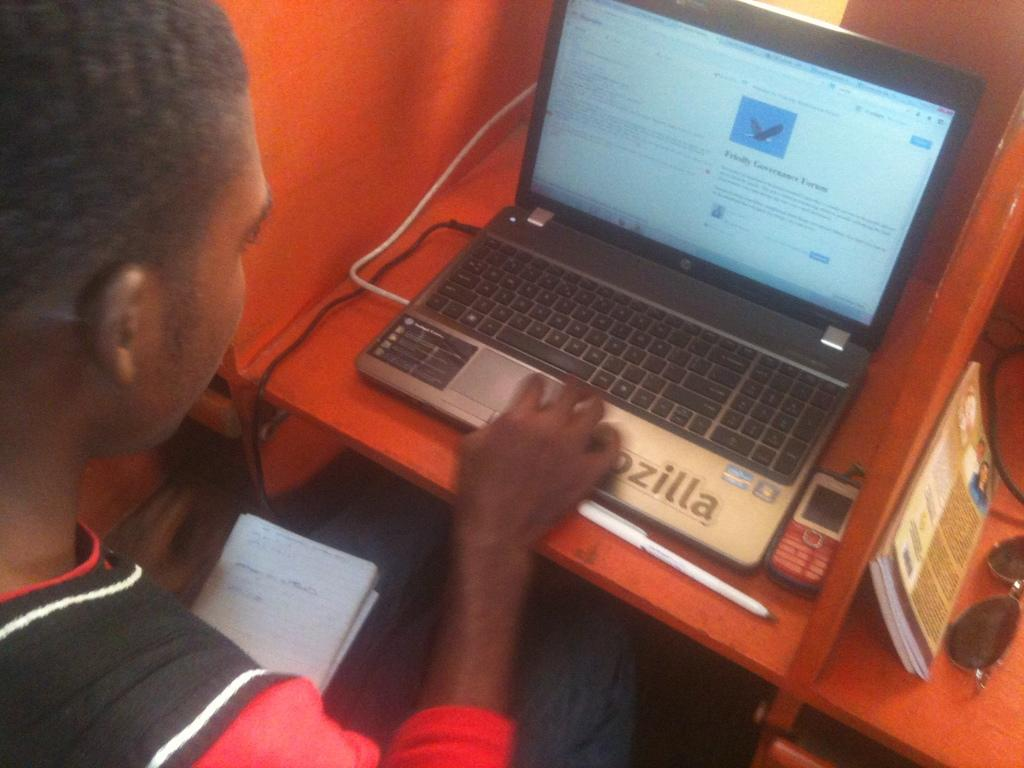<image>
Provide a brief description of the given image. A person is using a computer with the word Friendly on the screen under an eagle. 